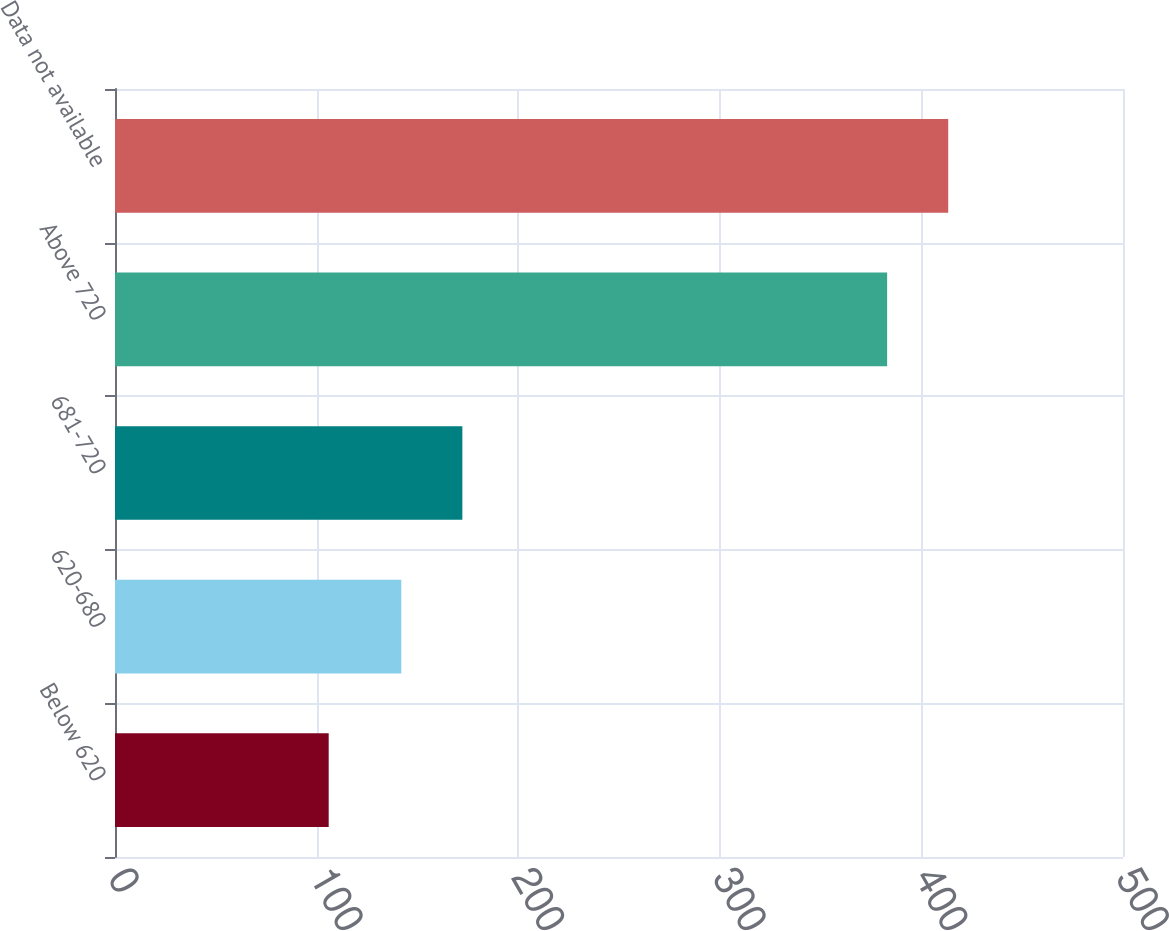Convert chart. <chart><loc_0><loc_0><loc_500><loc_500><bar_chart><fcel>Below 620<fcel>620-680<fcel>681-720<fcel>Above 720<fcel>Data not available<nl><fcel>106<fcel>142<fcel>172.3<fcel>383<fcel>413.3<nl></chart> 